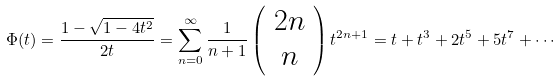<formula> <loc_0><loc_0><loc_500><loc_500>\Phi ( t ) = \frac { 1 - \sqrt { 1 - 4 t ^ { 2 } } } { 2 t } = \sum _ { n = 0 } ^ { \infty } \frac { 1 } { n + 1 } \left ( \begin{array} { c } 2 n \\ n \end{array} \right ) t ^ { 2 n + 1 } = t + t ^ { 3 } + 2 t ^ { 5 } + 5 t ^ { 7 } + \cdots</formula> 